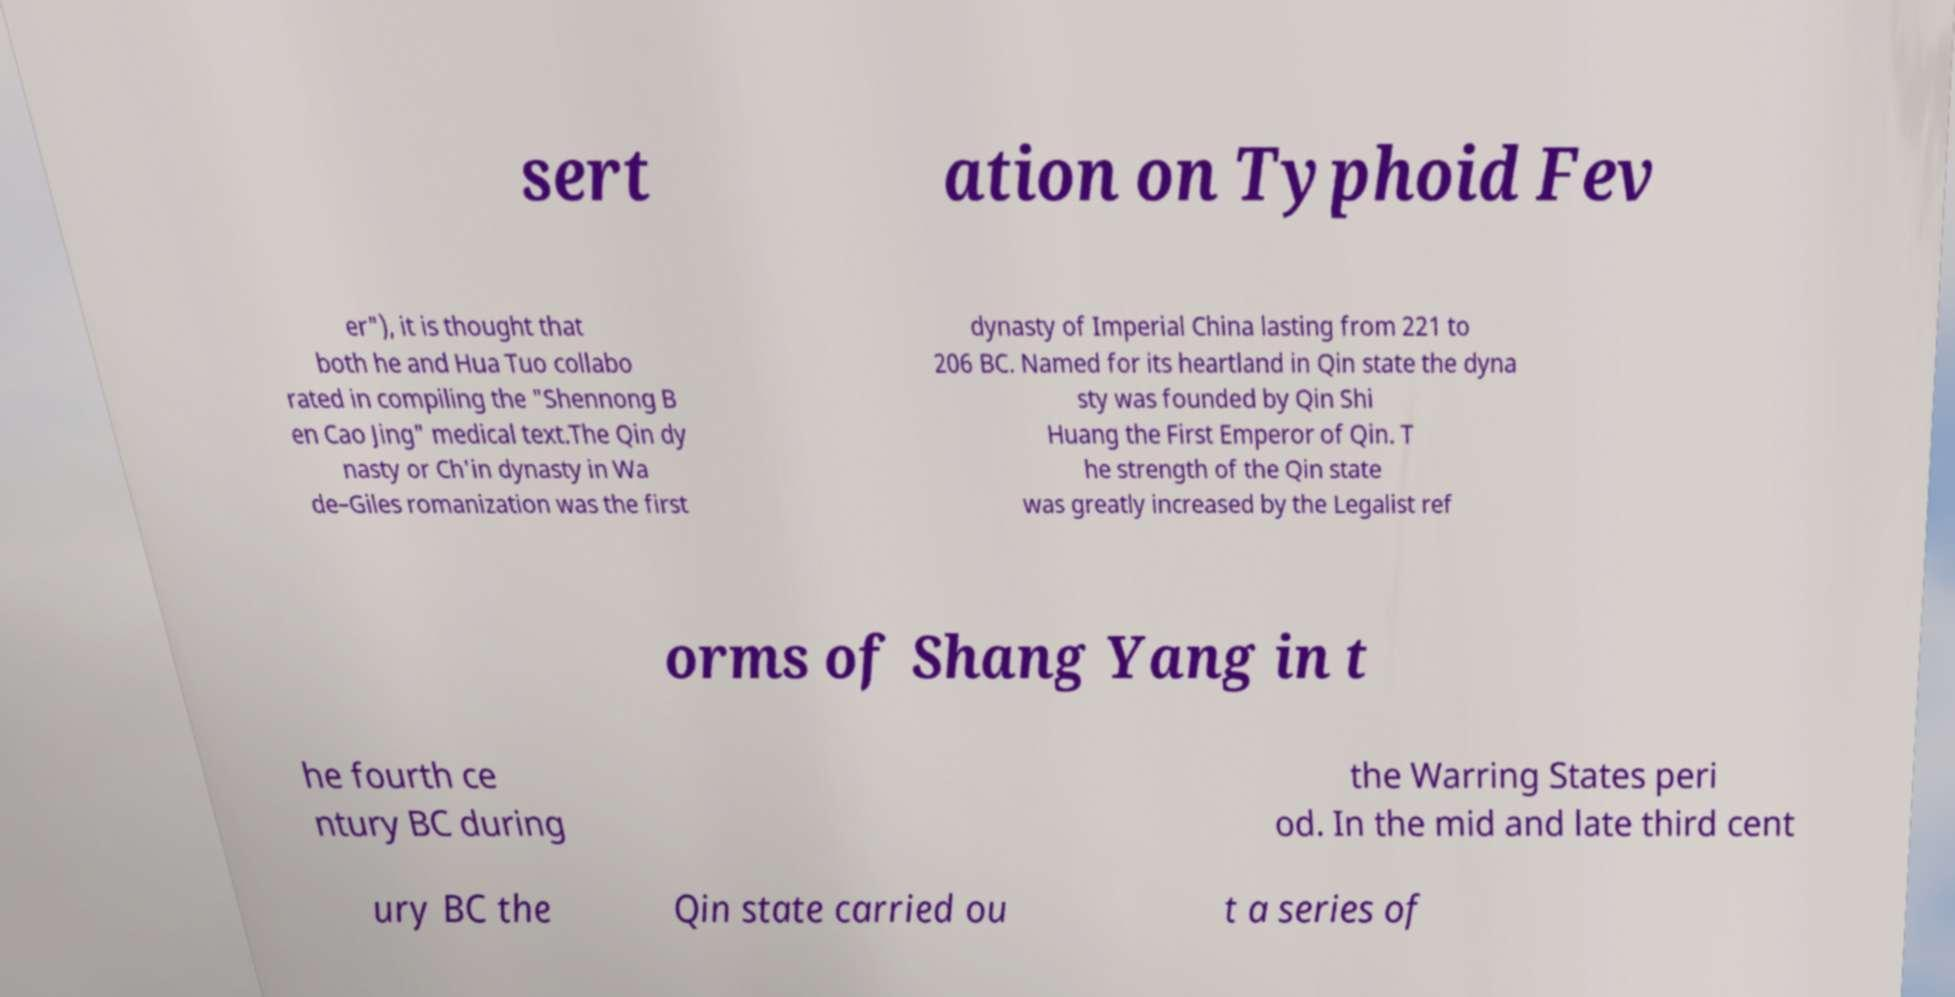I need the written content from this picture converted into text. Can you do that? sert ation on Typhoid Fev er"), it is thought that both he and Hua Tuo collabo rated in compiling the "Shennong B en Cao Jing" medical text.The Qin dy nasty or Ch'in dynasty in Wa de–Giles romanization was the first dynasty of Imperial China lasting from 221 to 206 BC. Named for its heartland in Qin state the dyna sty was founded by Qin Shi Huang the First Emperor of Qin. T he strength of the Qin state was greatly increased by the Legalist ref orms of Shang Yang in t he fourth ce ntury BC during the Warring States peri od. In the mid and late third cent ury BC the Qin state carried ou t a series of 